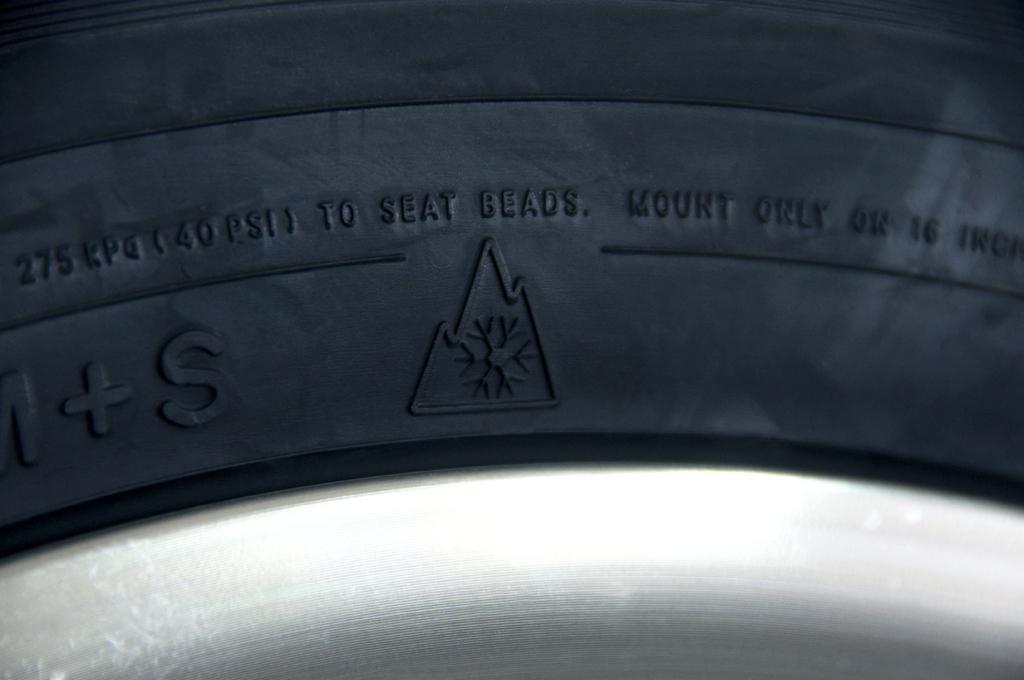In one or two sentences, can you explain what this image depicts? In this picture we can see a tyre and we can find some text on it. 